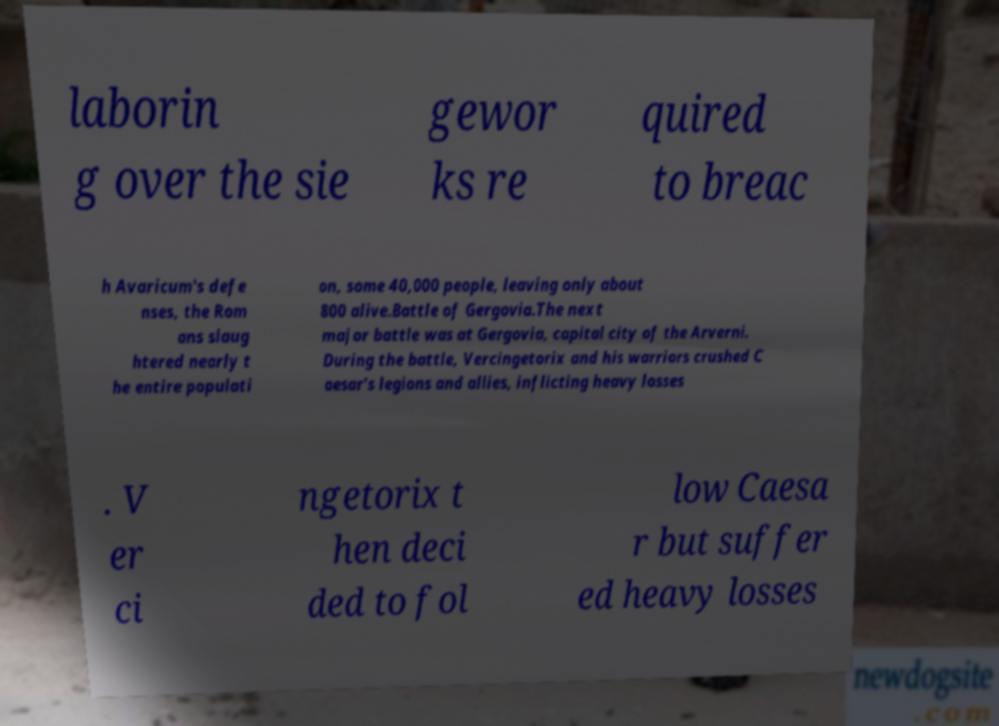Can you read and provide the text displayed in the image?This photo seems to have some interesting text. Can you extract and type it out for me? laborin g over the sie gewor ks re quired to breac h Avaricum's defe nses, the Rom ans slaug htered nearly t he entire populati on, some 40,000 people, leaving only about 800 alive.Battle of Gergovia.The next major battle was at Gergovia, capital city of the Arverni. During the battle, Vercingetorix and his warriors crushed C aesar's legions and allies, inflicting heavy losses . V er ci ngetorix t hen deci ded to fol low Caesa r but suffer ed heavy losses 